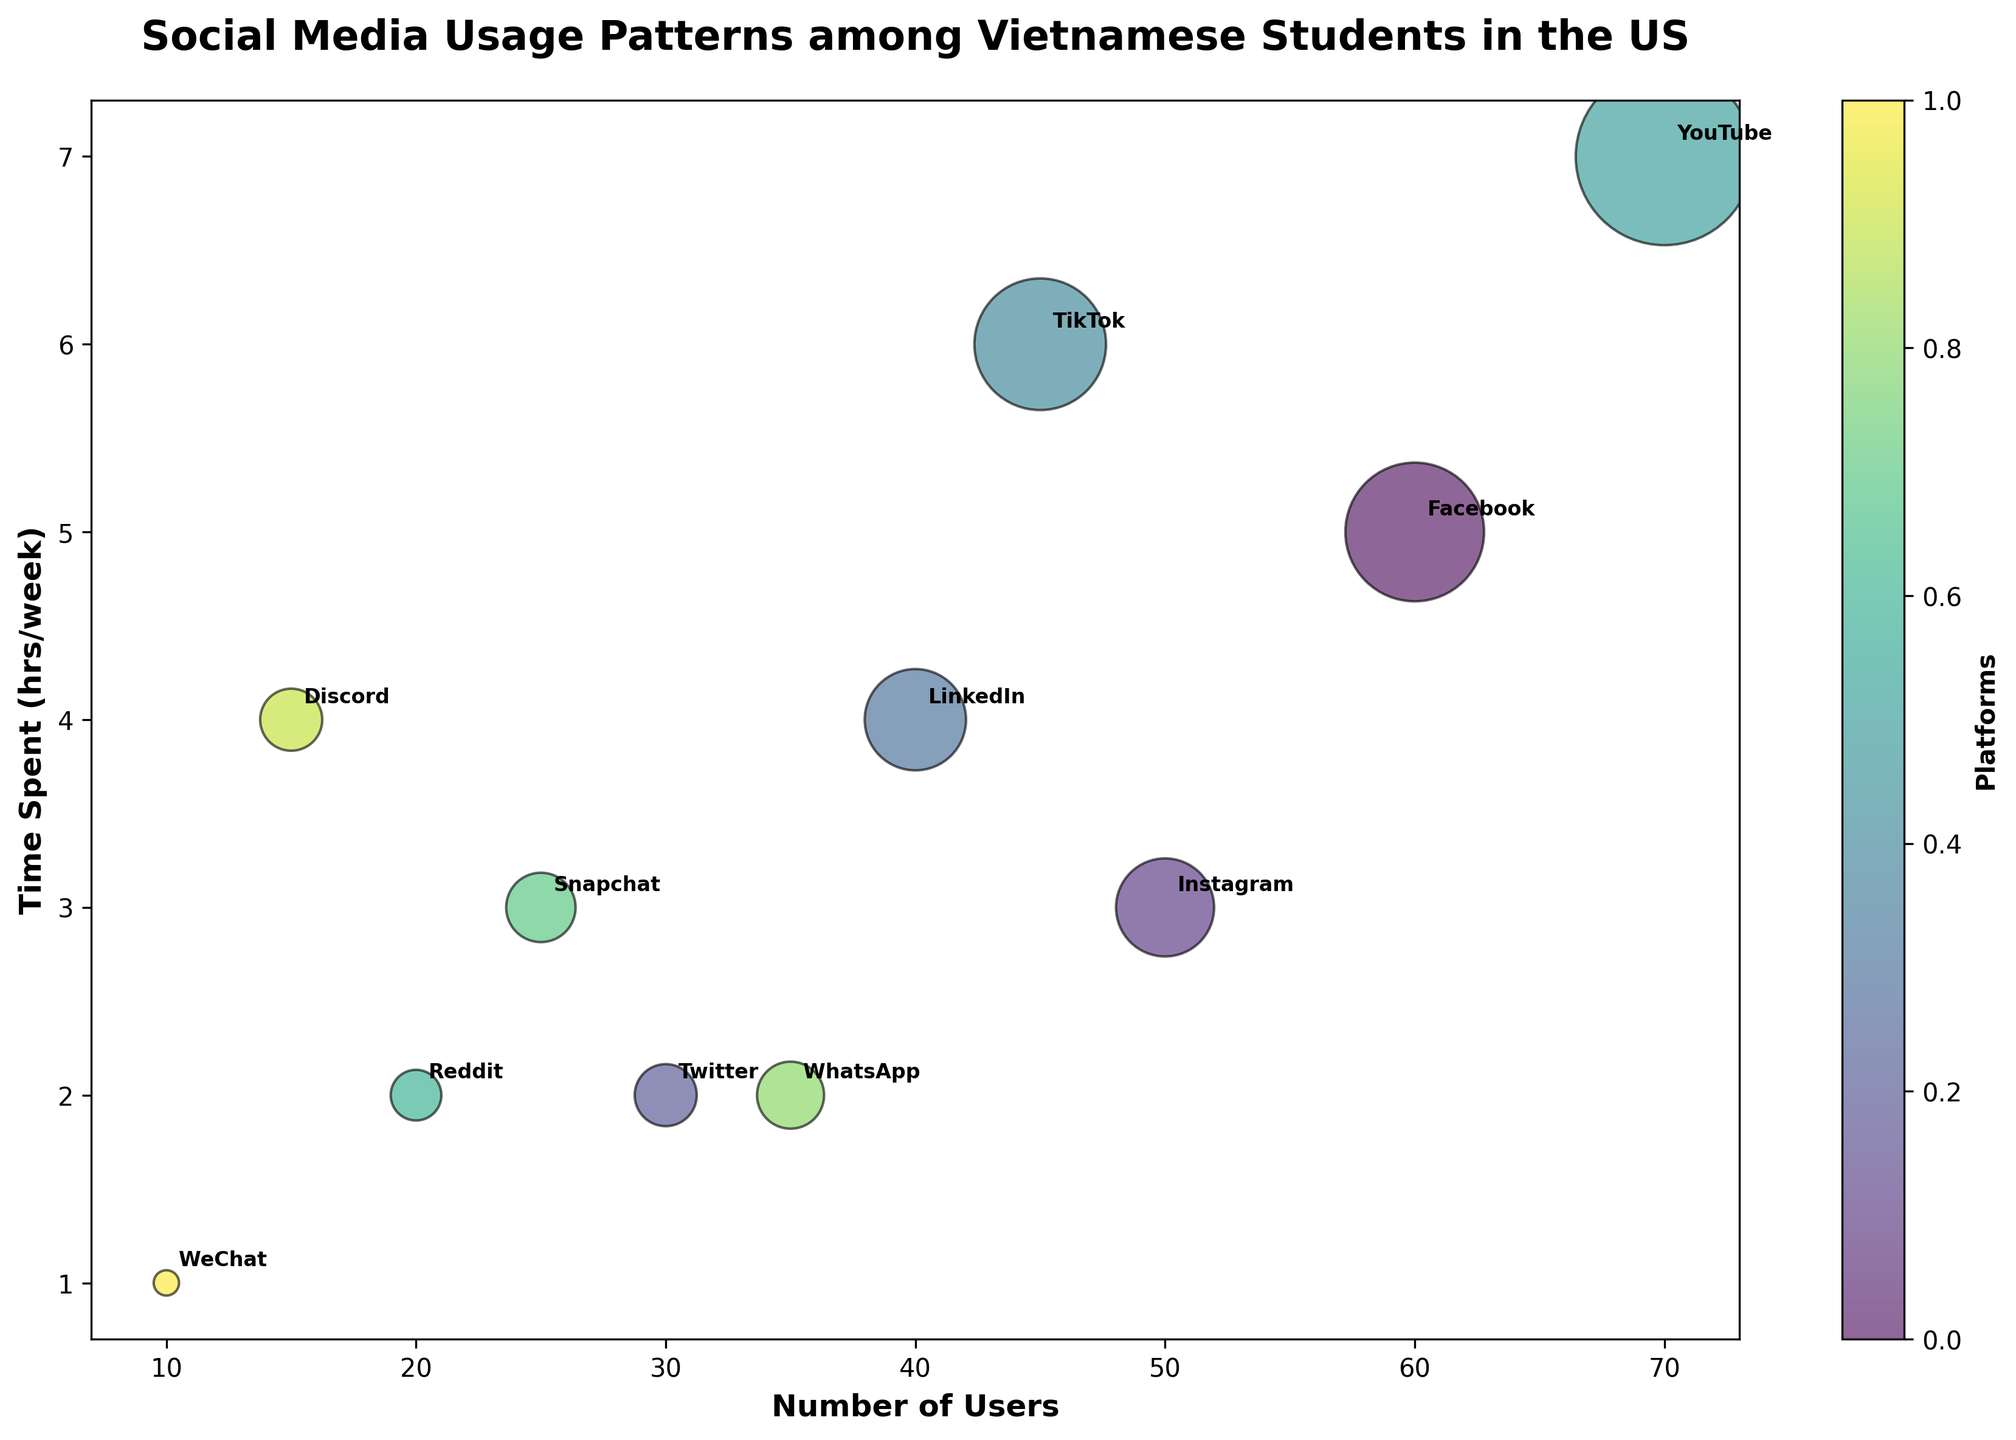What's the title of the figure? The title is placed at the top center of the plot. It is bold and in a larger font size for emphasis.
Answer: Social Media Usage Patterns among Vietnamese Students in the US How many different social media platforms are displayed in the figure? By counting the labeled bubbles, we see there are different social media platforms mentioned in the figure.
Answer: 11 Which platform has the highest number of users? Look for the x-axis value with the largest number, which is labeled with the platform name.
Answer: YouTube Which platform has the least amount of time spent per week? Look at the y-axis for the lowest value and check the corresponding bubble's label.
Answer: WeChat What is the average time spent on Reddit and Twitter? Find the Time Spent values for Reddit and Twitter, then calculate the average: \( \frac{2 + 2}{2} \).
Answer: 2 hours/week How does the number of users on LinkedIn compare to those on Snapchat? Compare the x-axis values for LinkedIn and Snapchat. LinkedIn has 40 users, while Snapchat has 25 users, so LinkedIn has more users.
Answer: LinkedIn has more users Which platform has the largest bubble size, and what does it represent? Look at the size of the bubbles. The largest bubble represents the platform with the most users multiplied by the time spent.
Answer: YouTube, representing 490 (70 users * 7 hrs/week) What is the total time spent per week on Facebook and TikTok combined? Add the y-axis values for Facebook and TikTok: \( 5 + 6 \).
Answer: 11 hours/week Compare the time spent on Instagram with the time spent on YouTube. Which one is higher? Look at the y-axis values for Instagram and YouTube. YouTube has a higher value (7 hours/week) compared to Instagram (3 hours/week).
Answer: YouTube is higher How does the platform WeChat differ in terms of users and time spent compared to Discord? Compare the x and y-axis values for WeChat and Discord. WeChat has fewer users (10) and less time spent (1 hr/week) than Discord, which has 15 users and 4 hrs/week.
Answer: WeChat has fewer users and less time spent 